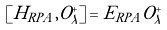<formula> <loc_0><loc_0><loc_500><loc_500>\left [ H _ { R P A } , O ^ { + } _ { \lambda } \right ] = E _ { R P A } O ^ { + } _ { \lambda }</formula> 